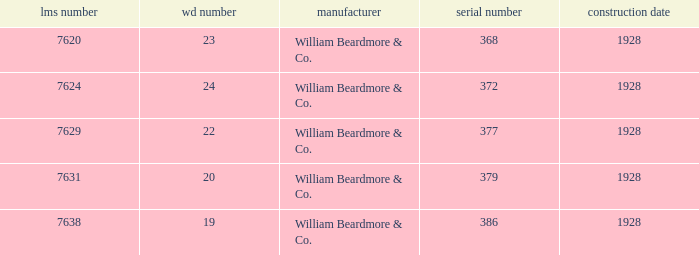Name the builder for serial number being 377 William Beardmore & Co. 